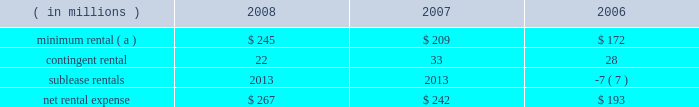Marathon oil corporation notes to consolidated financial statements operating lease rental expense was : ( in millions ) 2008 2007 2006 minimum rental ( a ) $ 245 $ 209 $ 172 .
( a ) excludes $ 5 million , $ 8 million and $ 9 million paid by united states steel in 2008 , 2007 and 2006 on assumed leases .
27 .
Contingencies and commitments we are the subject of , or party to , a number of pending or threatened legal actions , contingencies and commitments involving a variety of matters , including laws and regulations relating to the environment .
Certain of these matters are discussed below .
The ultimate resolution of these contingencies could , individually or in the aggregate , be material to our consolidated financial statements .
However , management believes that we will remain a viable and competitive enterprise even though it is possible that these contingencies could be resolved unfavorably .
Environmental matters 2013 we are subject to federal , state , local and foreign laws and regulations relating to the environment .
These laws generally provide for control of pollutants released into the environment and require responsible parties to undertake remediation of hazardous waste disposal sites .
Penalties may be imposed for noncompliance .
At december 31 , 2008 and 2007 , accrued liabilities for remediation totaled $ 111 million and $ 108 million .
It is not presently possible to estimate the ultimate amount of all remediation costs that might be incurred or the penalties that may be imposed .
Receivables for recoverable costs from certain states , under programs to assist companies in clean-up efforts related to underground storage tanks at retail marketing outlets , were $ 60 and $ 66 million at december 31 , 2008 and 2007 .
We are a defendant , along with other refining companies , in 20 cases arising in three states alleging damages for methyl tertiary-butyl ether ( 201cmtbe 201d ) contamination .
We have also received seven toxic substances control act notice letters involving potential claims in two states .
Such notice letters are often followed by litigation .
Like the cases that were settled in 2008 , the remaining mtbe cases are consolidated in a multidistrict litigation in the southern district of new york for pretrial proceedings .
Nineteen of the remaining cases allege damages to water supply wells , similar to the damages claimed in the settled cases .
In the other remaining case , the state of new jersey is seeking natural resources damages allegedly resulting from contamination of groundwater by mtbe .
This is the only mtbe contamination case in which we are a defendant and natural resources damages are sought .
We are vigorously defending these cases .
We , along with a number of other defendants , have engaged in settlement discussions related to the majority of the cases in which we are a defendant .
We do not expect our share of liability , if any , for the remaining cases to significantly impact our consolidated results of operations , financial position or cash flows .
A lawsuit filed in the united states district court for the southern district of west virginia alleges that our catlettsburg , kentucky , refinery distributed contaminated gasoline to wholesalers and retailers for a period prior to august , 2003 , causing permanent damage to storage tanks , dispensers and related equipment , resulting in lost profits , business disruption and personal and real property damages .
Following the incident , we conducted remediation operations at affected facilities , and we deny that any permanent damages resulted from the incident .
Class action certification was granted in august 2007 .
We have entered into a tentative settlement agreement in this case .
Notice of the proposed settlement has been sent to the class members .
Approval by the court after a fairness hearing is required before the settlement can be finalized .
The fairness hearing is scheduled in the first quarter of 2009 .
The proposed settlement will not significantly impact our consolidated results of operations , financial position or cash flows .
Guarantees 2013 we have provided certain guarantees , direct and indirect , of the indebtedness of other companies .
Under the terms of most of these guarantee arrangements , we would be required to perform should the guaranteed party fail to fulfill its obligations under the specified arrangements .
In addition to these financial guarantees , we also have various performance guarantees related to specific agreements. .
What was average contingent rental amount in millions for the three year period? 
Computations: table_average(contingent rental, none)
Answer: 27.66667. 